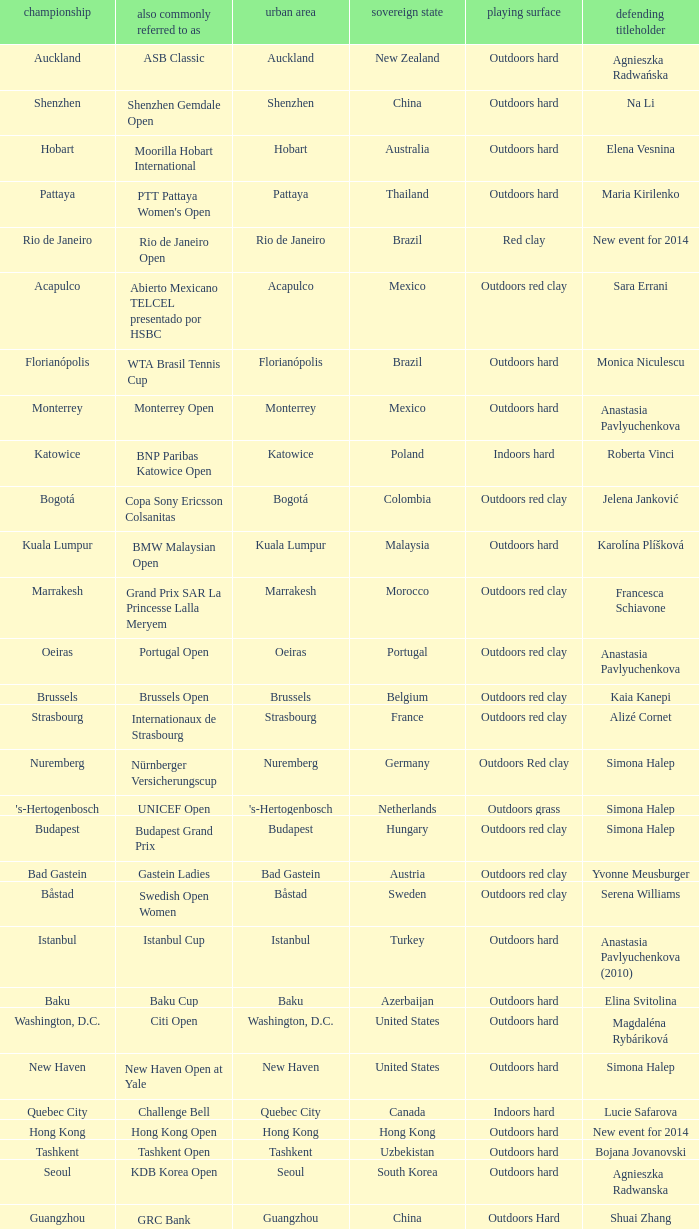How many defending champs from thailand? 1.0. 